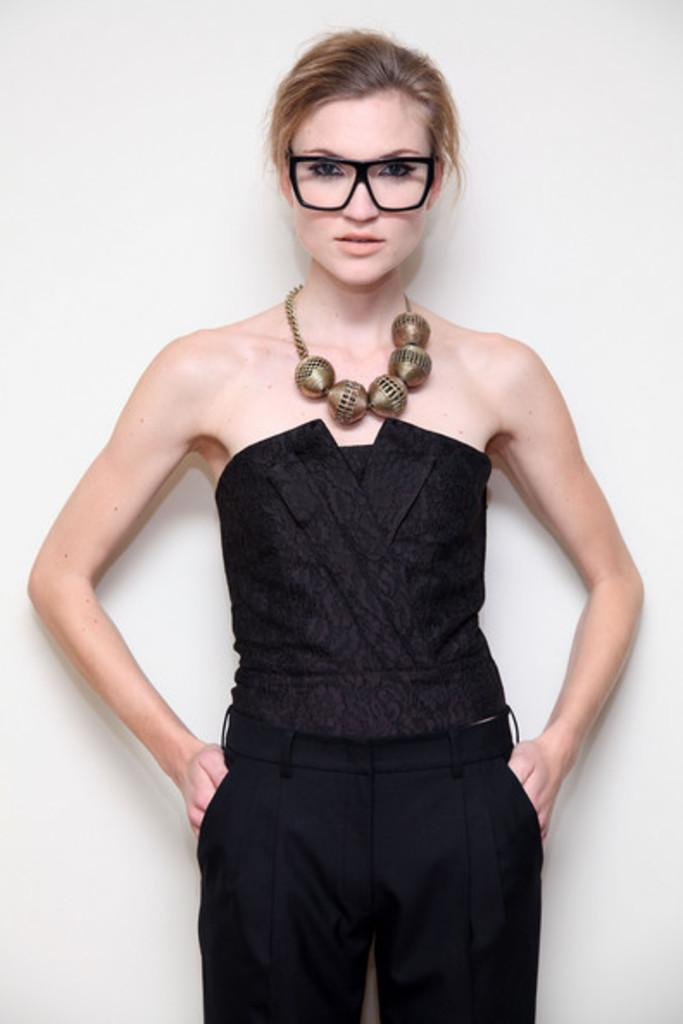Who is the main subject in the image? There is a woman in the image. What is the woman doing in the image? The woman is standing. What is the woman wearing in the image? The woman is wearing a black dress and a necklace. What is the color of the background in the image? The background of the image is white. What type of zinc is being used to style the woman's hair in the image? There is no mention of zinc or hair styling in the image. The woman is simply standing and wearing a black dress and a necklace. 